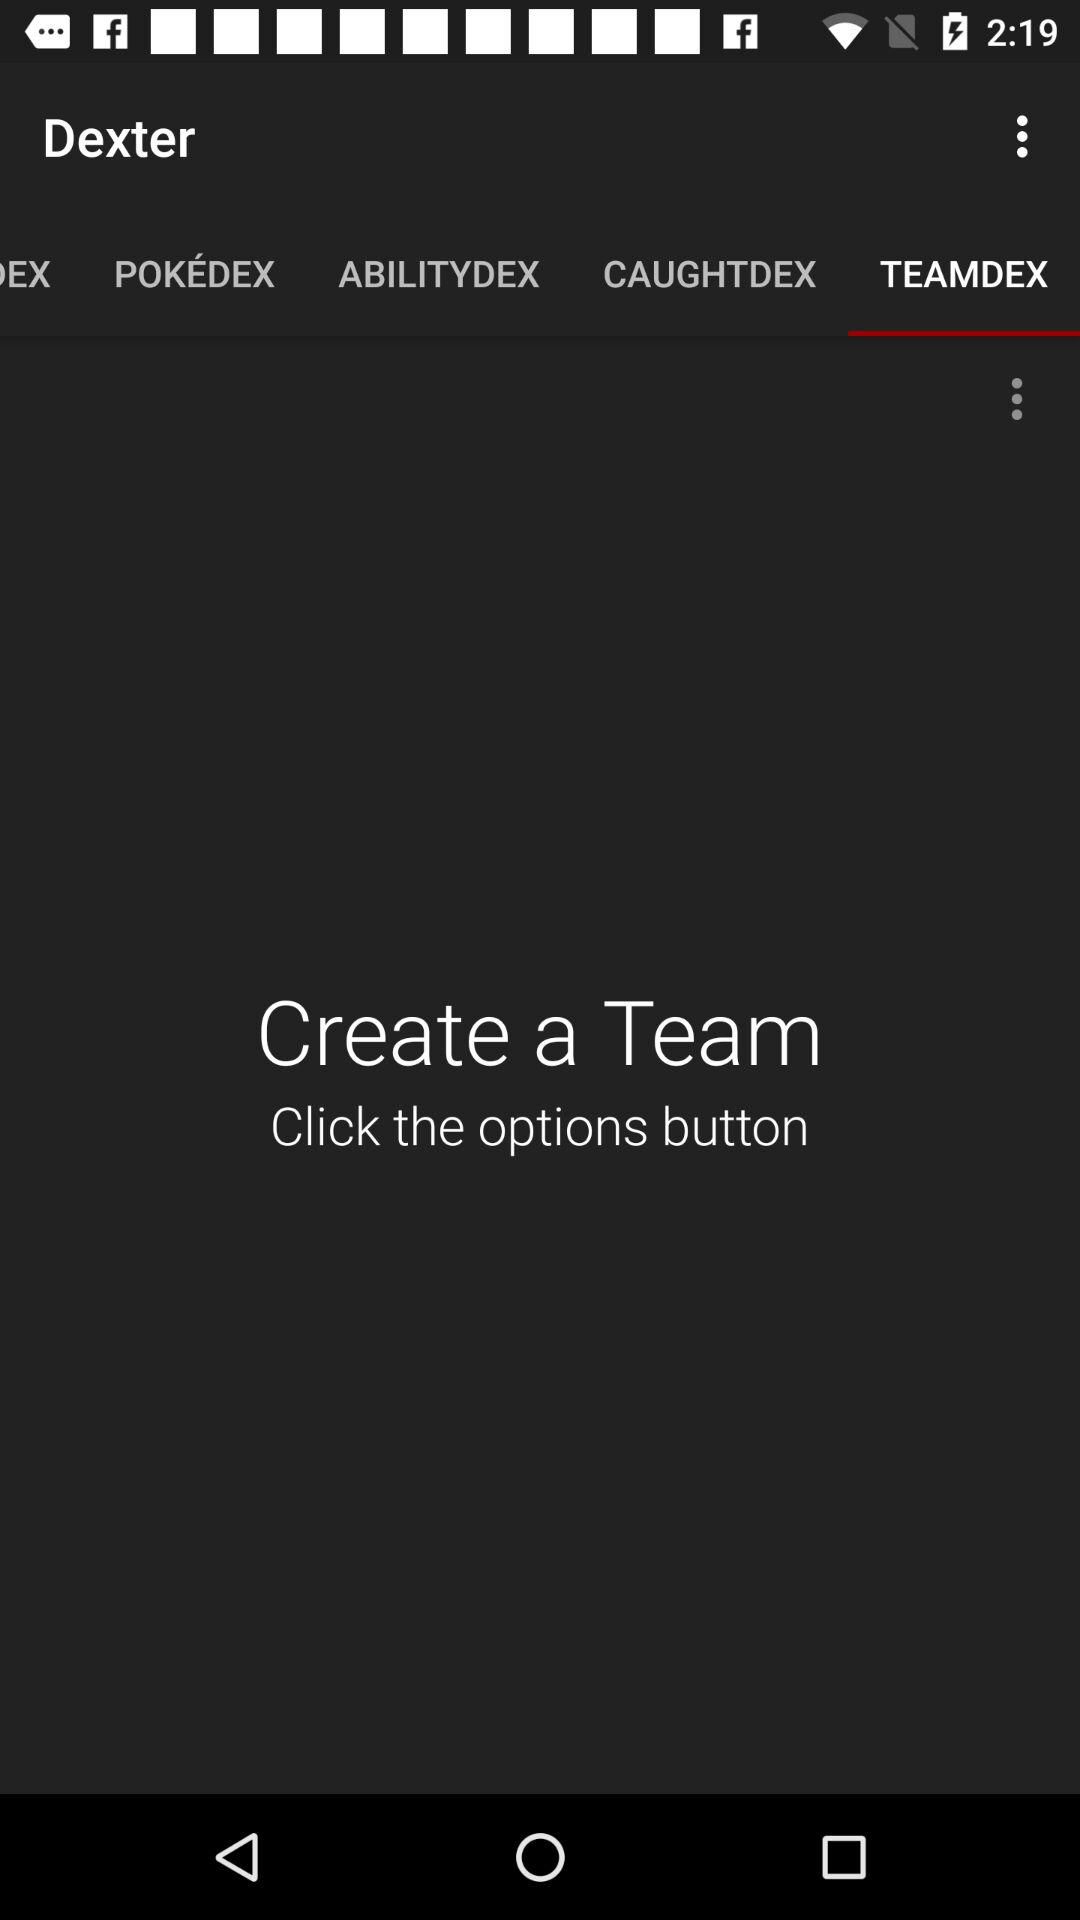What is the selected option? The selected option is "TEAMDEX". 